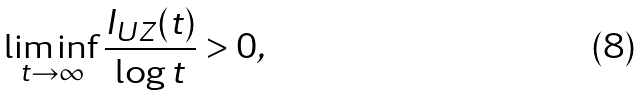Convert formula to latex. <formula><loc_0><loc_0><loc_500><loc_500>\liminf _ { t \to \infty } \frac { I _ { U Z } ( t ) } { \log t } & > 0 ,</formula> 